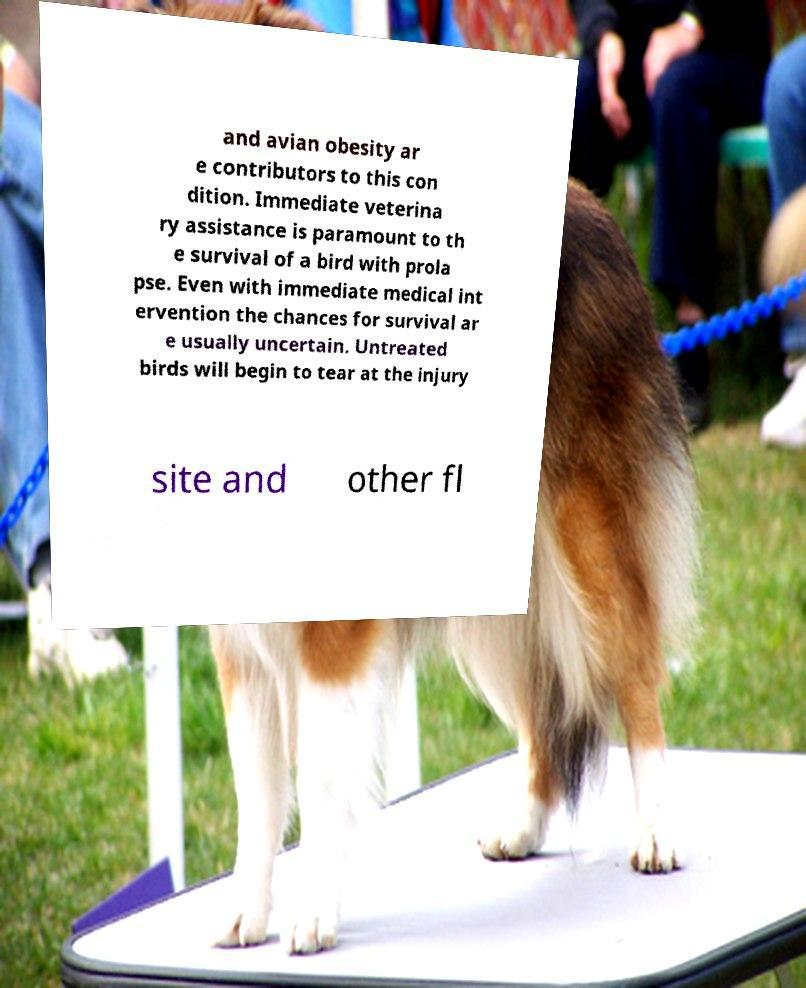Please identify and transcribe the text found in this image. and avian obesity ar e contributors to this con dition. Immediate veterina ry assistance is paramount to th e survival of a bird with prola pse. Even with immediate medical int ervention the chances for survival ar e usually uncertain. Untreated birds will begin to tear at the injury site and other fl 